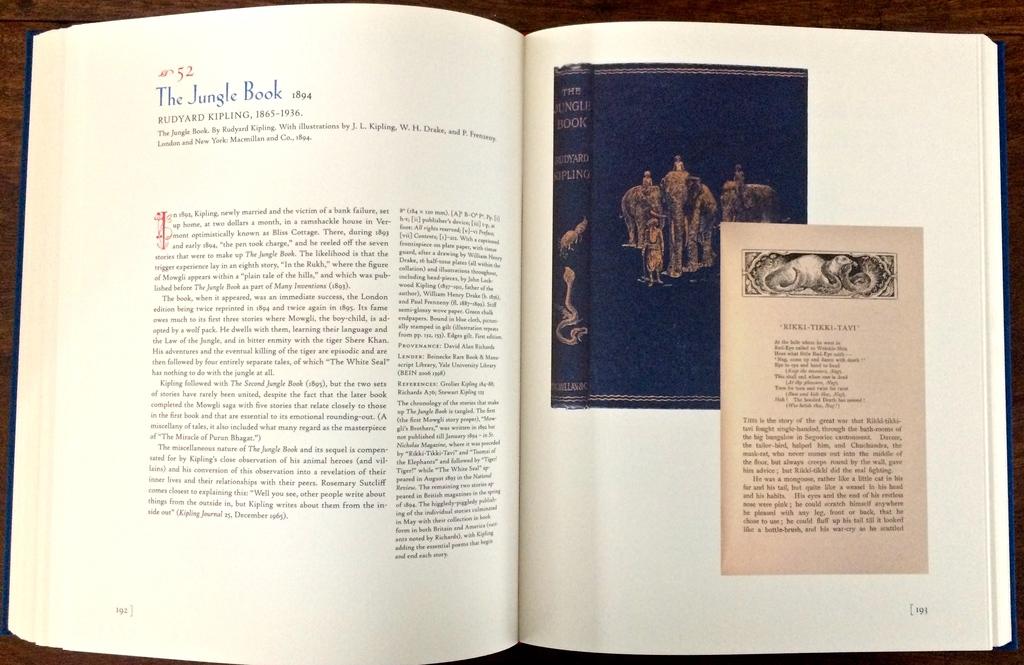What classic book is being shown on the pages?
Keep it short and to the point. The jungle book. What is the number at the top in red?
Keep it short and to the point. 52. 